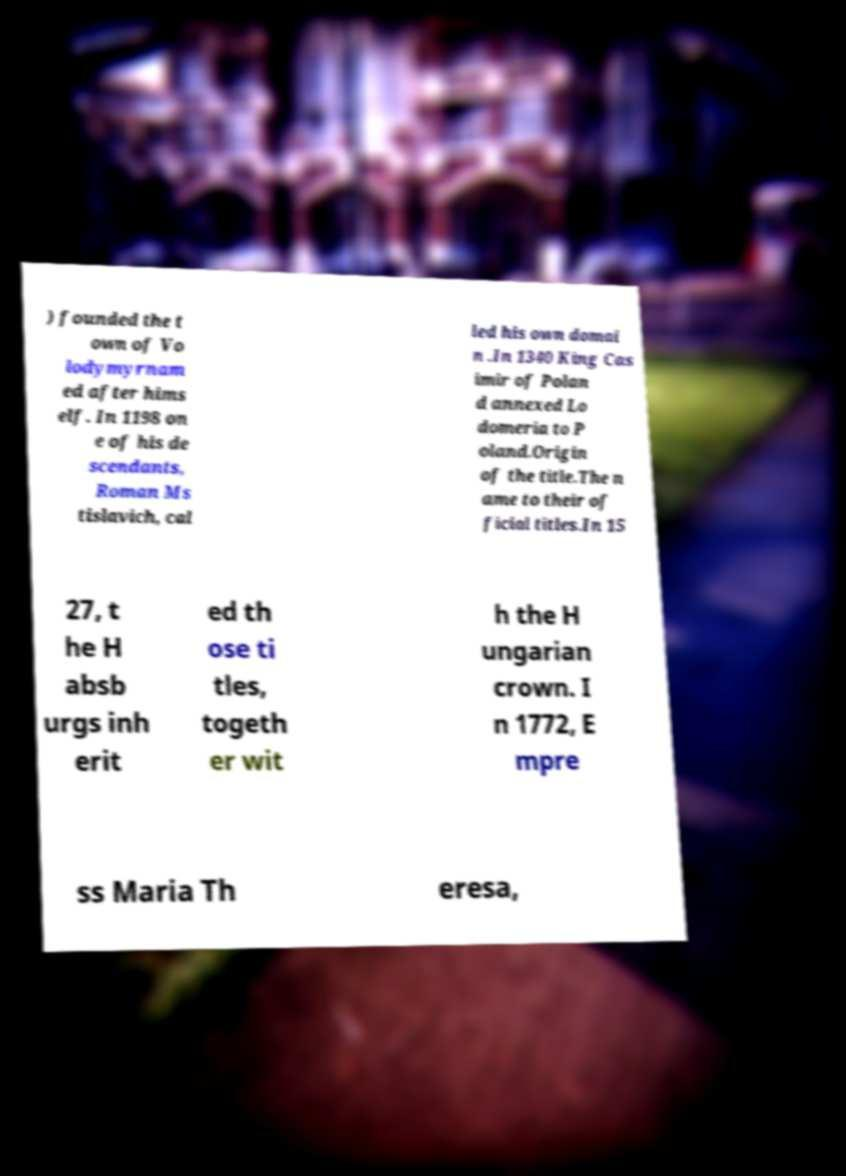What messages or text are displayed in this image? I need them in a readable, typed format. ) founded the t own of Vo lodymyrnam ed after hims elf. In 1198 on e of his de scendants, Roman Ms tislavich, cal led his own domai n .In 1340 King Cas imir of Polan d annexed Lo domeria to P oland.Origin of the title.The n ame to their of ficial titles.In 15 27, t he H absb urgs inh erit ed th ose ti tles, togeth er wit h the H ungarian crown. I n 1772, E mpre ss Maria Th eresa, 